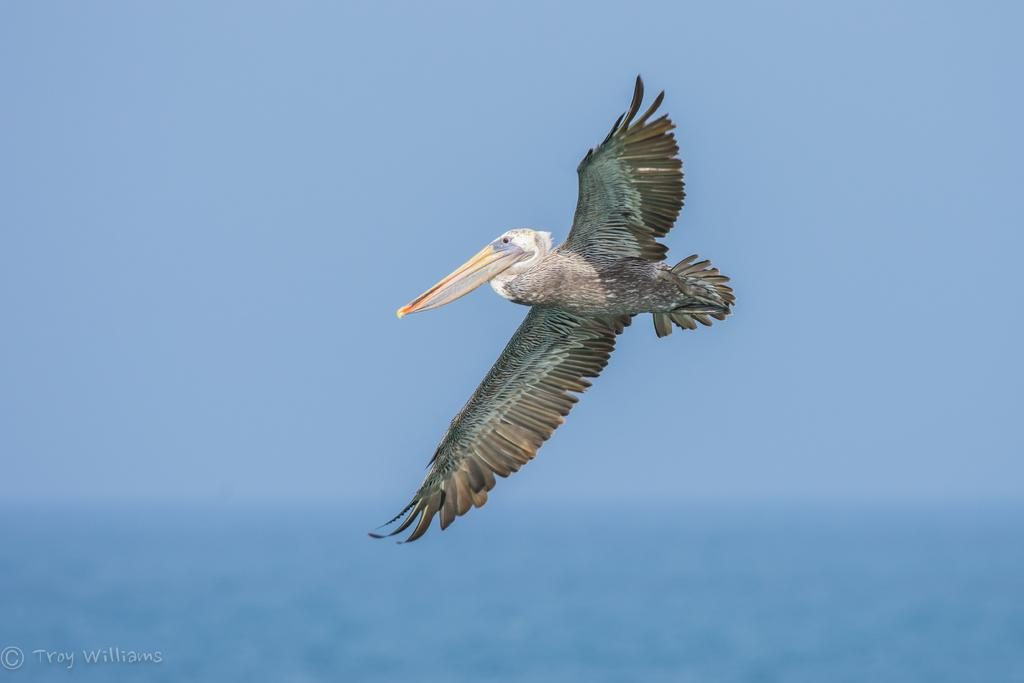What is the main subject of the image? The main subject of the image is a bird flying in the air. What else can be seen in the image besides the bird? There is water and the sky visible in the image. Is there any text present in the image? Yes, there is text in the bottom left corner of the image. What type of test is being conducted in the room shown in the image? There is no room or test present in the image; it features a bird flying in the air with water and the sky visible. Can you describe the mother's reaction to the event in the image? There is no mother or event present in the image; it features a bird flying in the air with water and the sky visible. 